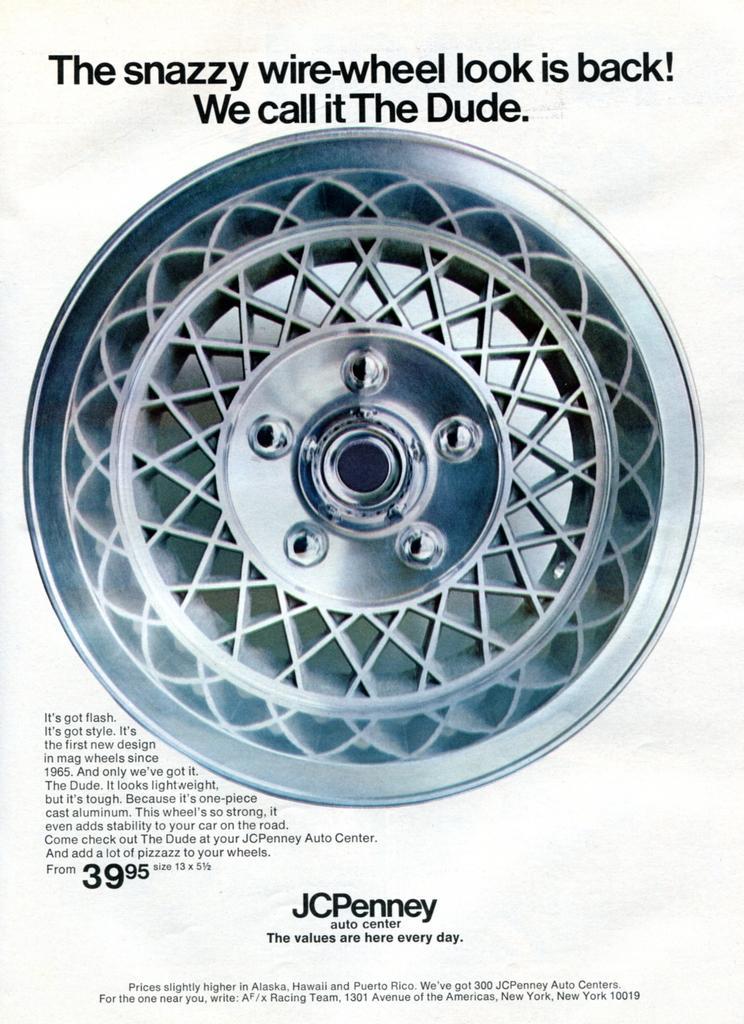How would you summarize this image in a sentence or two? In the center of the image we can see wheel. At the top and bottom of the image we can see text. 